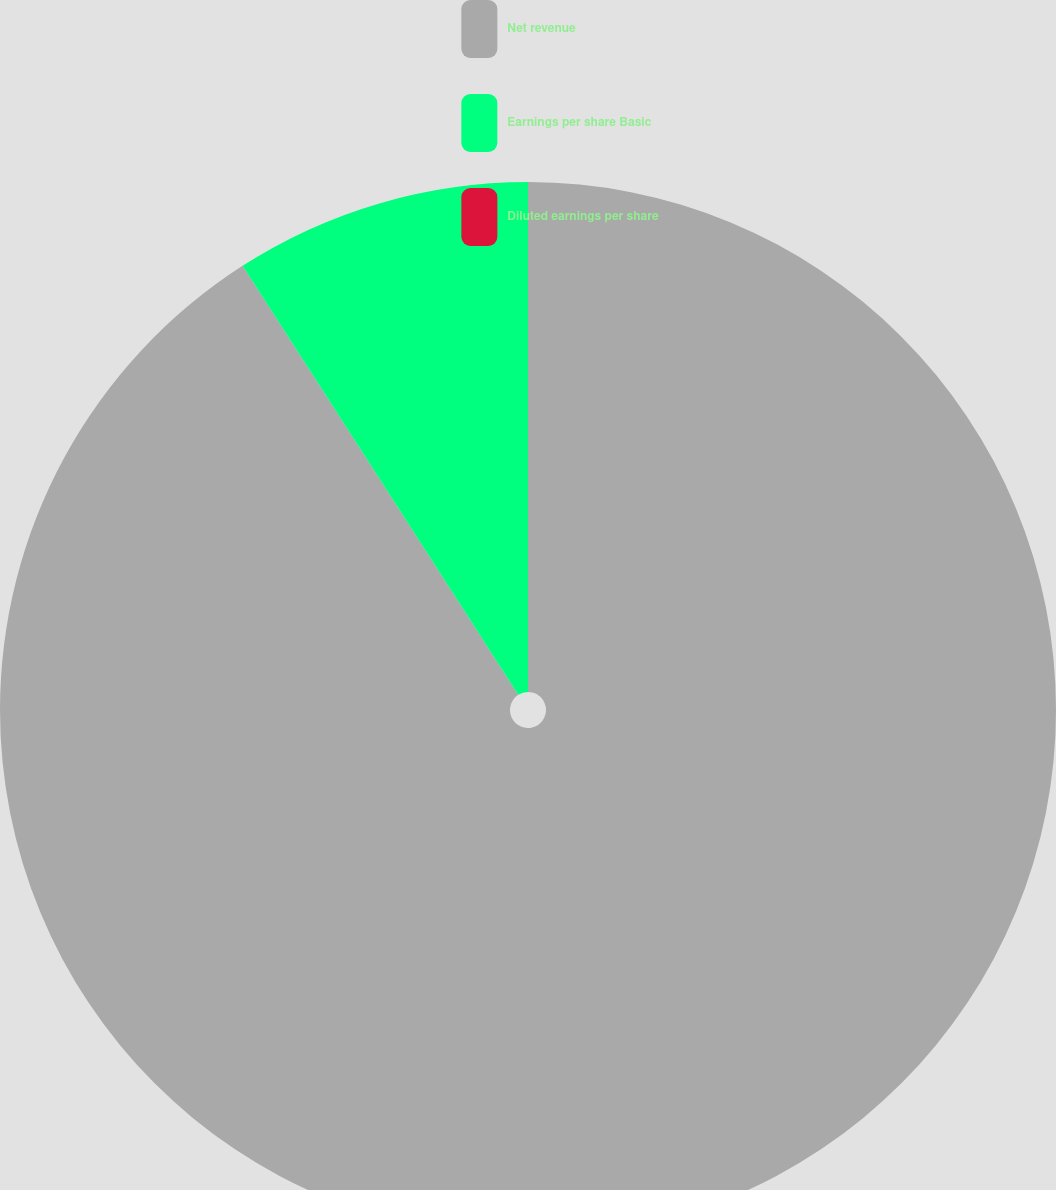<chart> <loc_0><loc_0><loc_500><loc_500><pie_chart><fcel>Net revenue<fcel>Earnings per share Basic<fcel>Diluted earnings per share<nl><fcel>90.91%<fcel>9.09%<fcel>0.0%<nl></chart> 